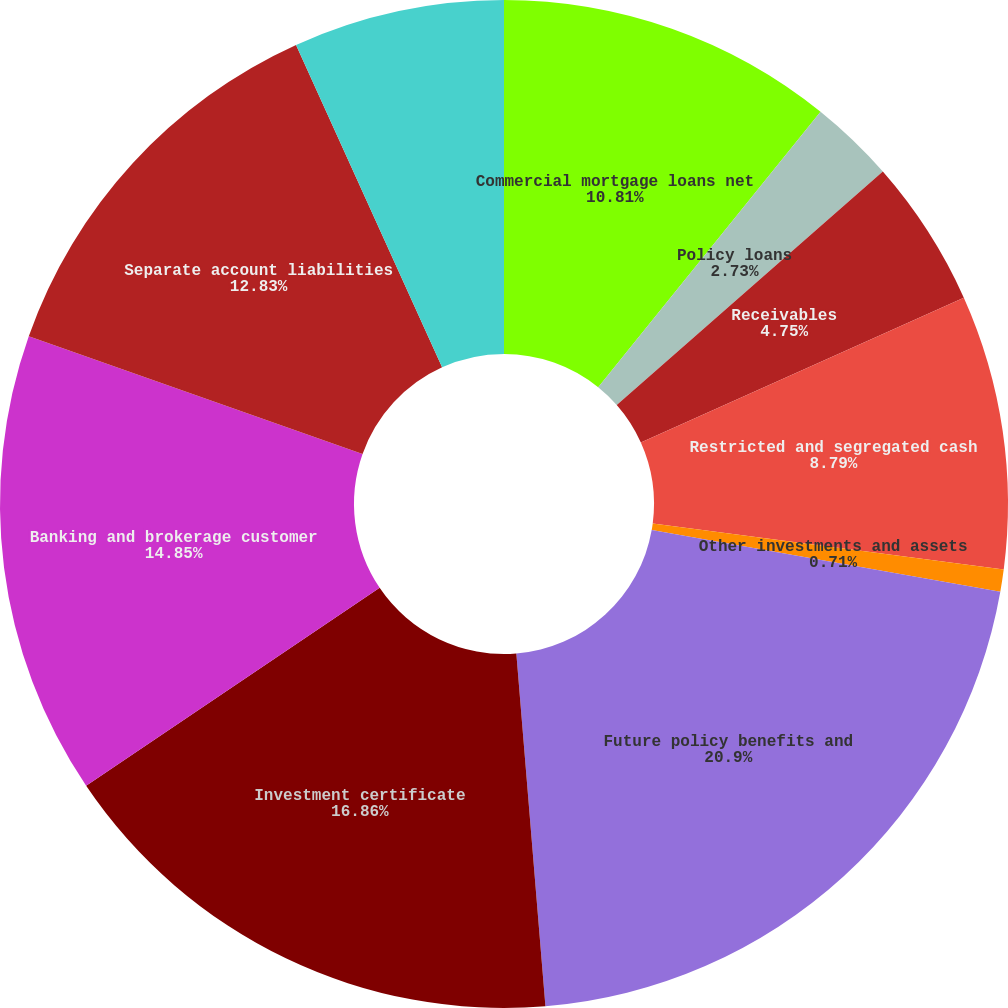Convert chart. <chart><loc_0><loc_0><loc_500><loc_500><pie_chart><fcel>Commercial mortgage loans net<fcel>Policy loans<fcel>Receivables<fcel>Restricted and segregated cash<fcel>Other investments and assets<fcel>Future policy benefits and<fcel>Investment certificate<fcel>Banking and brokerage customer<fcel>Separate account liabilities<fcel>Debt and other liabilities<nl><fcel>10.81%<fcel>2.73%<fcel>4.75%<fcel>8.79%<fcel>0.71%<fcel>20.91%<fcel>16.87%<fcel>14.85%<fcel>12.83%<fcel>6.77%<nl></chart> 